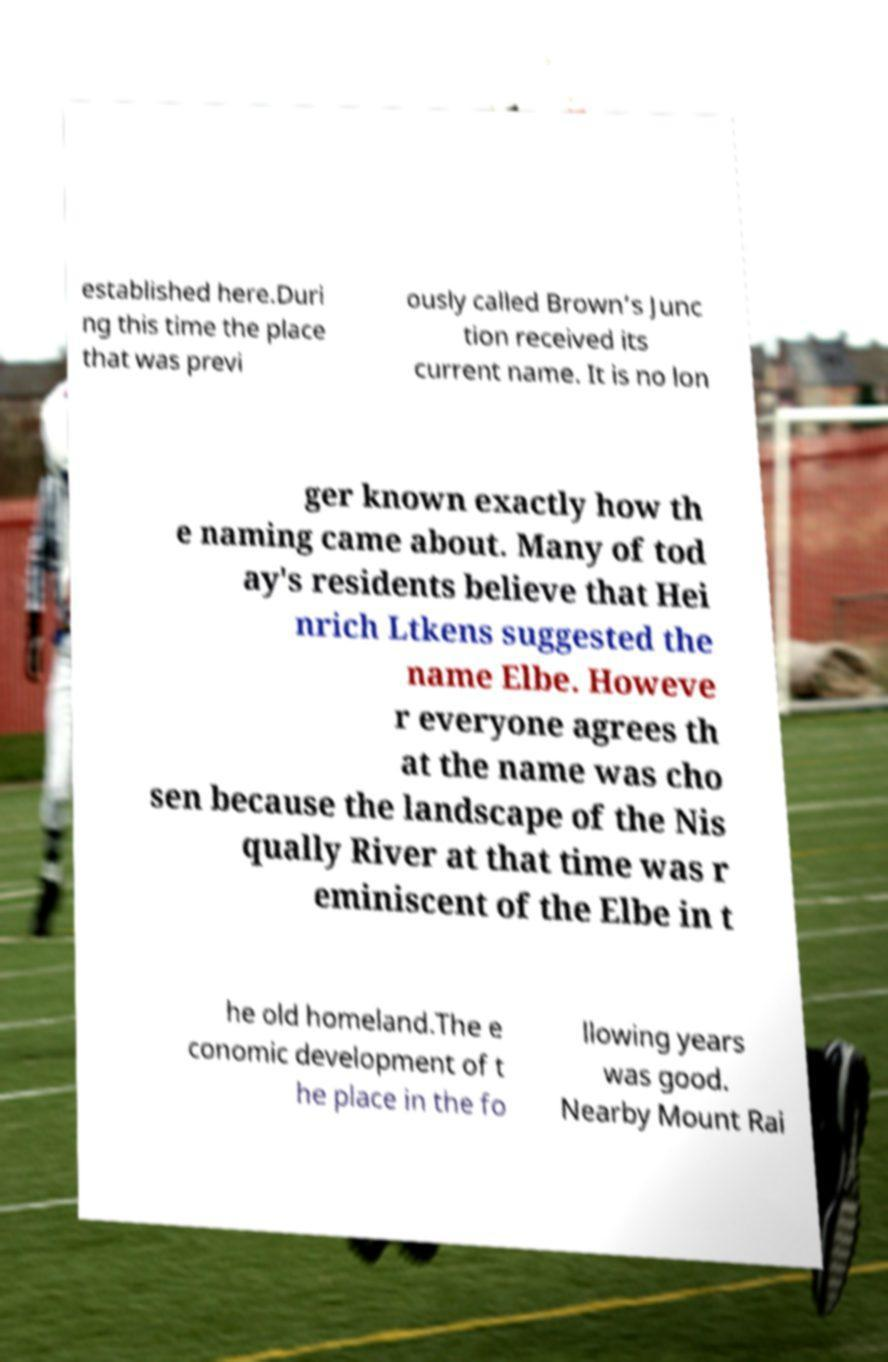Please read and relay the text visible in this image. What does it say? established here.Duri ng this time the place that was previ ously called Brown’s Junc tion received its current name. It is no lon ger known exactly how th e naming came about. Many of tod ay's residents believe that Hei nrich Ltkens suggested the name Elbe. Howeve r everyone agrees th at the name was cho sen because the landscape of the Nis qually River at that time was r eminiscent of the Elbe in t he old homeland.The e conomic development of t he place in the fo llowing years was good. Nearby Mount Rai 